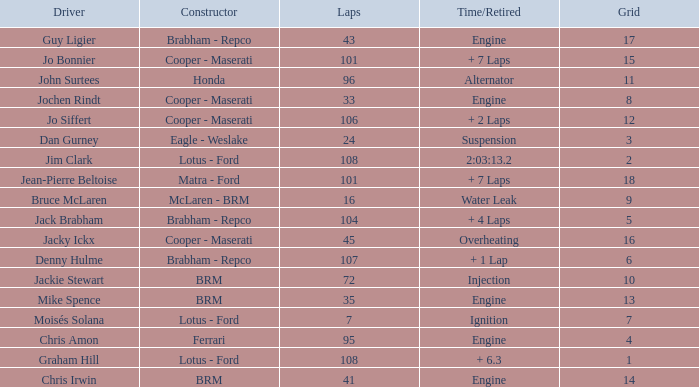What was the constructor when there were 95 laps and a grid less than 15? Ferrari. 